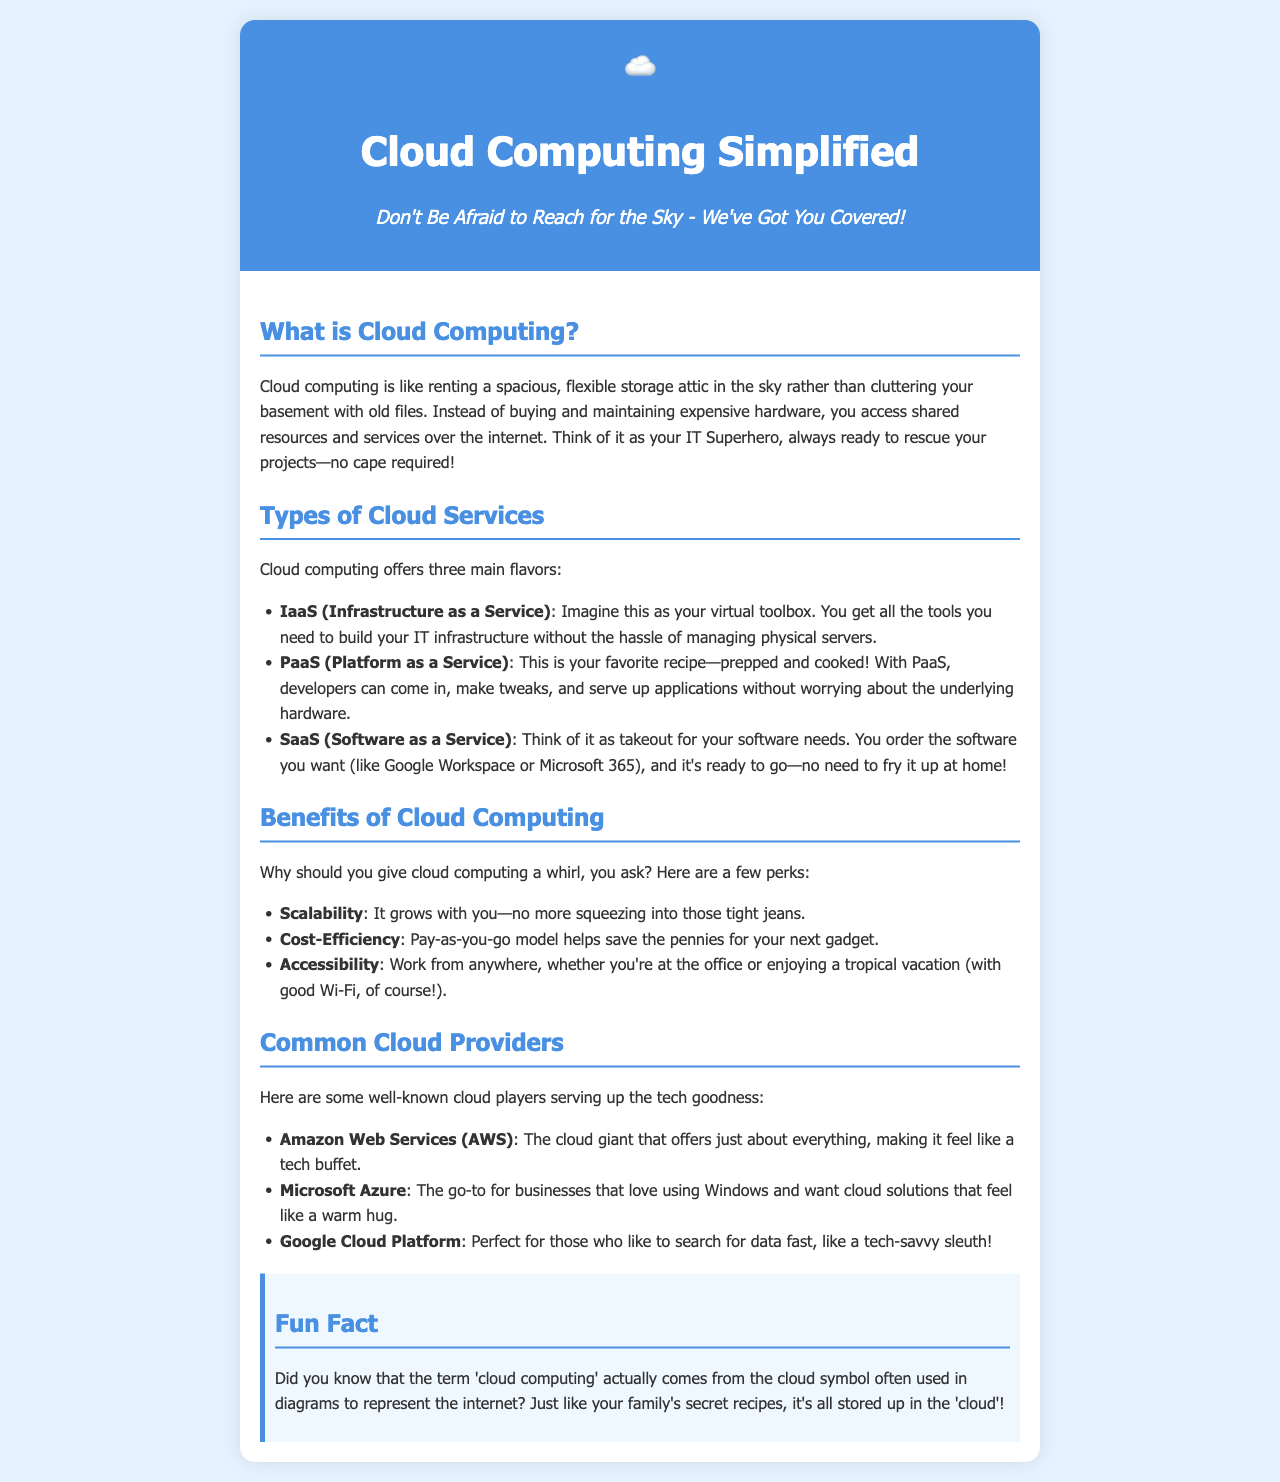What is cloud computing? Cloud computing is described in the document as renting a spacious storage attic instead of maintaining physical hardware.
Answer: Renting a spacious storage attic What are the three main types of cloud services? The document lists three cloud service types: Infrastructure as a Service, Platform as a Service, and Software as a Service.
Answer: IaaS, PaaS, SaaS What benefit of cloud computing relates to adjusting resource needs? The document mentions scalability as a benefit that allows for growth and adjustment to needs.
Answer: Scalability Which cloud provider is referred to as a tech buffet? Amazon Web Services (AWS) is described as the cloud giant offering a variety of services.
Answer: Amazon Web Services (AWS) What fun fact is included about the term 'cloud computing'? The document states that the term derives from the cloud symbol used in diagrams for the internet.
Answer: Cloud symbol in diagrams How does the document suggest you might work using cloud computing? The document mentions accessibility as a benefit that allows working from anywhere as long as there is good Wi-Fi.
Answer: From anywhere Which cloud service is likened to takeout? The document compares Software as a Service to takeout for software needs.
Answer: Software as a Service What does PaaS stand for? The document directly identifies PaaS as Platform as a Service.
Answer: Platform as a Service 